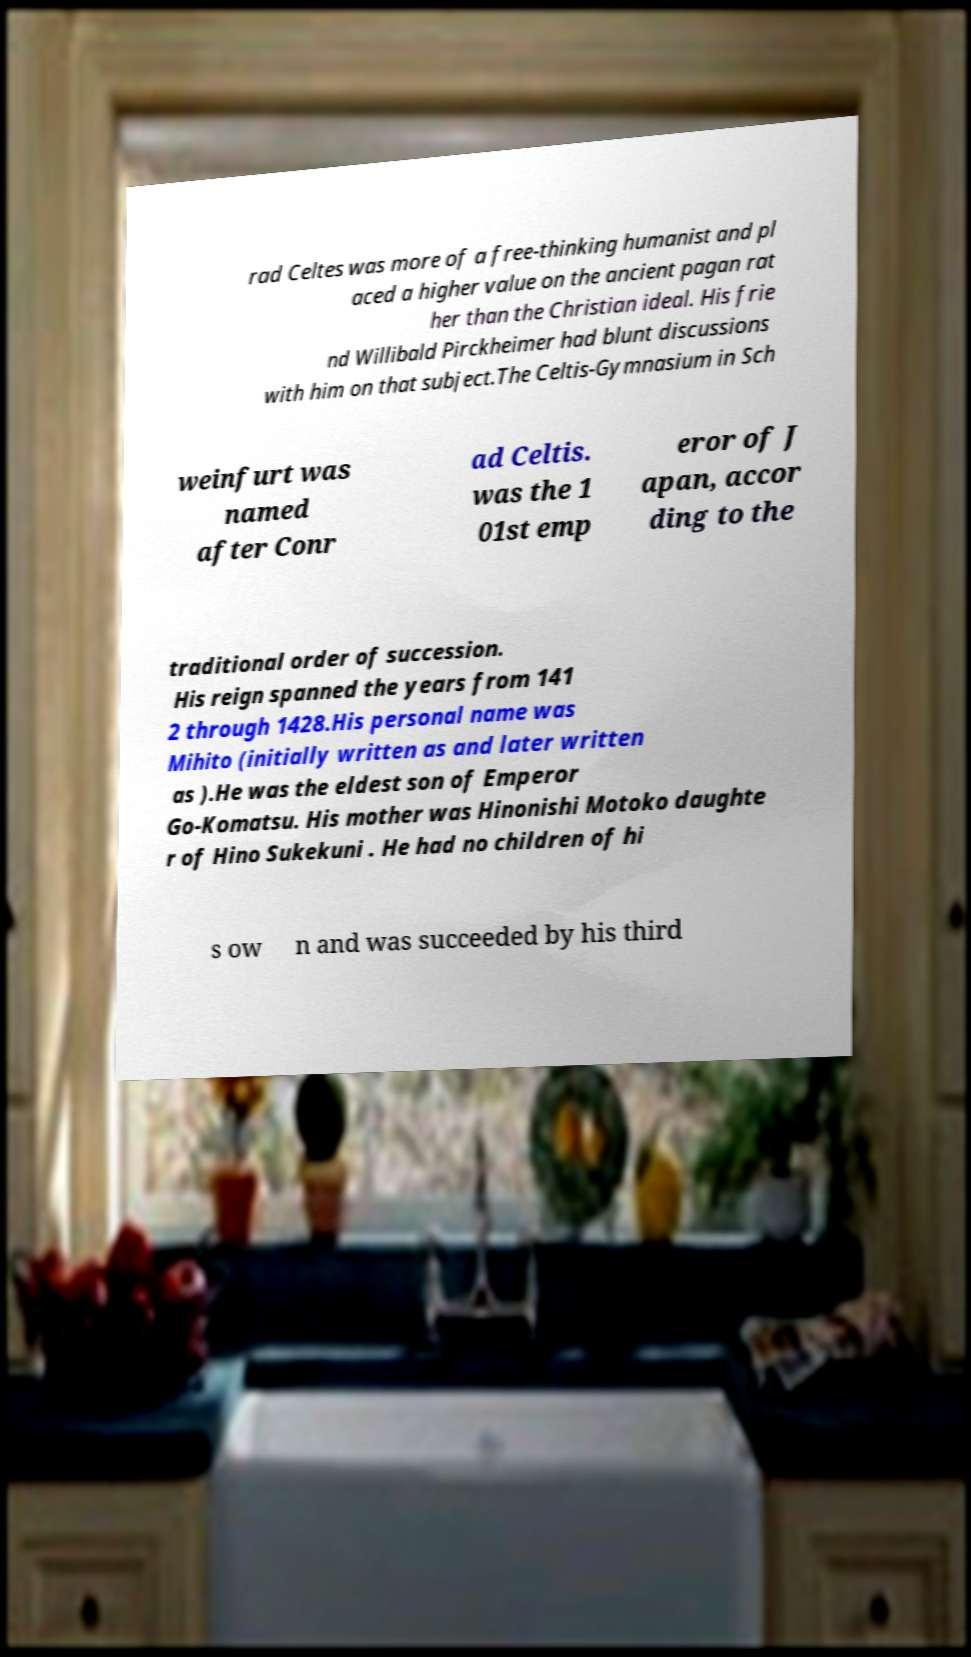Can you accurately transcribe the text from the provided image for me? rad Celtes was more of a free-thinking humanist and pl aced a higher value on the ancient pagan rat her than the Christian ideal. His frie nd Willibald Pirckheimer had blunt discussions with him on that subject.The Celtis-Gymnasium in Sch weinfurt was named after Conr ad Celtis. was the 1 01st emp eror of J apan, accor ding to the traditional order of succession. His reign spanned the years from 141 2 through 1428.His personal name was Mihito (initially written as and later written as ).He was the eldest son of Emperor Go-Komatsu. His mother was Hinonishi Motoko daughte r of Hino Sukekuni . He had no children of hi s ow n and was succeeded by his third 